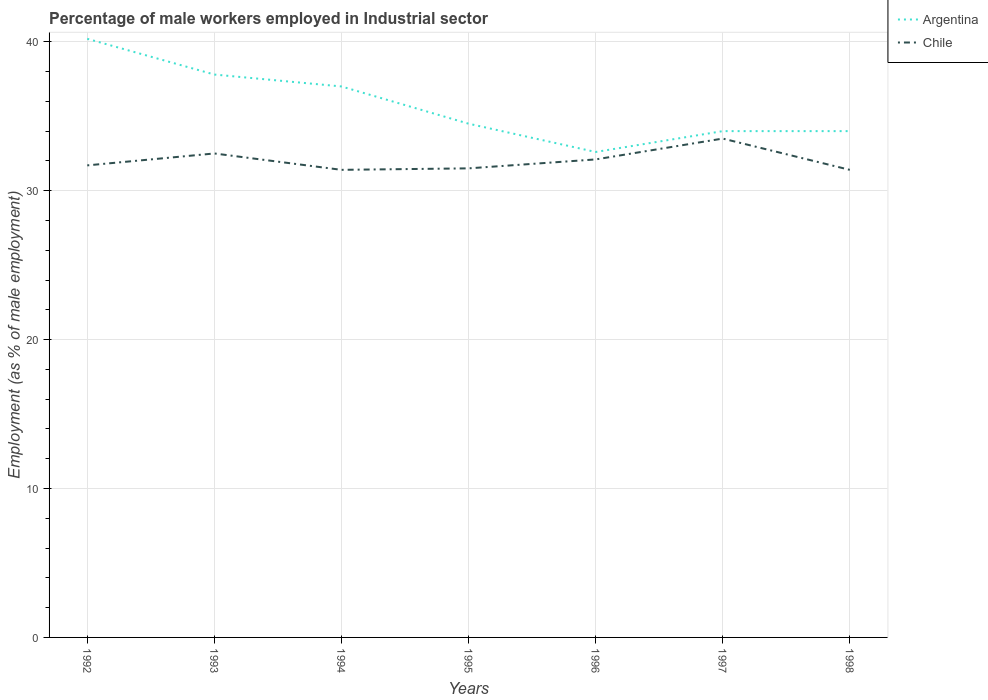Does the line corresponding to Argentina intersect with the line corresponding to Chile?
Give a very brief answer. No. Is the number of lines equal to the number of legend labels?
Your answer should be compact. Yes. Across all years, what is the maximum percentage of male workers employed in Industrial sector in Chile?
Your answer should be very brief. 31.4. In which year was the percentage of male workers employed in Industrial sector in Argentina maximum?
Your answer should be very brief. 1996. What is the total percentage of male workers employed in Industrial sector in Argentina in the graph?
Offer a terse response. 2.5. What is the difference between the highest and the second highest percentage of male workers employed in Industrial sector in Chile?
Provide a succinct answer. 2.1. Is the percentage of male workers employed in Industrial sector in Argentina strictly greater than the percentage of male workers employed in Industrial sector in Chile over the years?
Keep it short and to the point. No. How many years are there in the graph?
Offer a terse response. 7. What is the difference between two consecutive major ticks on the Y-axis?
Make the answer very short. 10. Are the values on the major ticks of Y-axis written in scientific E-notation?
Ensure brevity in your answer.  No. Does the graph contain any zero values?
Your answer should be compact. No. Where does the legend appear in the graph?
Your answer should be compact. Top right. How many legend labels are there?
Your answer should be compact. 2. What is the title of the graph?
Offer a terse response. Percentage of male workers employed in Industrial sector. What is the label or title of the Y-axis?
Offer a terse response. Employment (as % of male employment). What is the Employment (as % of male employment) of Argentina in 1992?
Offer a terse response. 40.2. What is the Employment (as % of male employment) of Chile in 1992?
Offer a very short reply. 31.7. What is the Employment (as % of male employment) in Argentina in 1993?
Offer a very short reply. 37.8. What is the Employment (as % of male employment) of Chile in 1993?
Give a very brief answer. 32.5. What is the Employment (as % of male employment) in Chile in 1994?
Provide a succinct answer. 31.4. What is the Employment (as % of male employment) of Argentina in 1995?
Keep it short and to the point. 34.5. What is the Employment (as % of male employment) in Chile in 1995?
Your response must be concise. 31.5. What is the Employment (as % of male employment) in Argentina in 1996?
Offer a terse response. 32.6. What is the Employment (as % of male employment) of Chile in 1996?
Your answer should be very brief. 32.1. What is the Employment (as % of male employment) of Argentina in 1997?
Provide a short and direct response. 34. What is the Employment (as % of male employment) of Chile in 1997?
Make the answer very short. 33.5. What is the Employment (as % of male employment) of Chile in 1998?
Your answer should be very brief. 31.4. Across all years, what is the maximum Employment (as % of male employment) of Argentina?
Keep it short and to the point. 40.2. Across all years, what is the maximum Employment (as % of male employment) in Chile?
Provide a short and direct response. 33.5. Across all years, what is the minimum Employment (as % of male employment) in Argentina?
Your response must be concise. 32.6. Across all years, what is the minimum Employment (as % of male employment) in Chile?
Provide a succinct answer. 31.4. What is the total Employment (as % of male employment) of Argentina in the graph?
Your answer should be compact. 250.1. What is the total Employment (as % of male employment) in Chile in the graph?
Give a very brief answer. 224.1. What is the difference between the Employment (as % of male employment) of Argentina in 1992 and that in 1993?
Give a very brief answer. 2.4. What is the difference between the Employment (as % of male employment) in Argentina in 1992 and that in 1994?
Offer a very short reply. 3.2. What is the difference between the Employment (as % of male employment) in Chile in 1992 and that in 1994?
Your answer should be very brief. 0.3. What is the difference between the Employment (as % of male employment) of Chile in 1992 and that in 1996?
Make the answer very short. -0.4. What is the difference between the Employment (as % of male employment) in Chile in 1992 and that in 1998?
Provide a short and direct response. 0.3. What is the difference between the Employment (as % of male employment) of Argentina in 1993 and that in 1994?
Provide a short and direct response. 0.8. What is the difference between the Employment (as % of male employment) in Chile in 1993 and that in 1994?
Make the answer very short. 1.1. What is the difference between the Employment (as % of male employment) of Chile in 1993 and that in 1995?
Keep it short and to the point. 1. What is the difference between the Employment (as % of male employment) of Argentina in 1993 and that in 1997?
Ensure brevity in your answer.  3.8. What is the difference between the Employment (as % of male employment) in Argentina in 1993 and that in 1998?
Keep it short and to the point. 3.8. What is the difference between the Employment (as % of male employment) in Argentina in 1994 and that in 1995?
Offer a terse response. 2.5. What is the difference between the Employment (as % of male employment) in Argentina in 1994 and that in 1996?
Your answer should be compact. 4.4. What is the difference between the Employment (as % of male employment) of Chile in 1994 and that in 1996?
Offer a terse response. -0.7. What is the difference between the Employment (as % of male employment) in Argentina in 1994 and that in 1998?
Provide a succinct answer. 3. What is the difference between the Employment (as % of male employment) of Chile in 1994 and that in 1998?
Offer a terse response. 0. What is the difference between the Employment (as % of male employment) of Argentina in 1995 and that in 1996?
Give a very brief answer. 1.9. What is the difference between the Employment (as % of male employment) of Chile in 1995 and that in 1996?
Your answer should be very brief. -0.6. What is the difference between the Employment (as % of male employment) of Argentina in 1995 and that in 1997?
Give a very brief answer. 0.5. What is the difference between the Employment (as % of male employment) of Chile in 1995 and that in 1997?
Your response must be concise. -2. What is the difference between the Employment (as % of male employment) of Argentina in 1995 and that in 1998?
Provide a succinct answer. 0.5. What is the difference between the Employment (as % of male employment) in Chile in 1996 and that in 1997?
Provide a short and direct response. -1.4. What is the difference between the Employment (as % of male employment) of Argentina in 1997 and that in 1998?
Give a very brief answer. 0. What is the difference between the Employment (as % of male employment) in Chile in 1997 and that in 1998?
Offer a terse response. 2.1. What is the difference between the Employment (as % of male employment) of Argentina in 1992 and the Employment (as % of male employment) of Chile in 1994?
Provide a succinct answer. 8.8. What is the difference between the Employment (as % of male employment) of Argentina in 1993 and the Employment (as % of male employment) of Chile in 1995?
Make the answer very short. 6.3. What is the difference between the Employment (as % of male employment) of Argentina in 1993 and the Employment (as % of male employment) of Chile in 1996?
Your response must be concise. 5.7. What is the difference between the Employment (as % of male employment) in Argentina in 1993 and the Employment (as % of male employment) in Chile in 1998?
Keep it short and to the point. 6.4. What is the difference between the Employment (as % of male employment) in Argentina in 1994 and the Employment (as % of male employment) in Chile in 1996?
Give a very brief answer. 4.9. What is the difference between the Employment (as % of male employment) in Argentina in 1994 and the Employment (as % of male employment) in Chile in 1997?
Ensure brevity in your answer.  3.5. What is the difference between the Employment (as % of male employment) of Argentina in 1995 and the Employment (as % of male employment) of Chile in 1997?
Provide a succinct answer. 1. What is the difference between the Employment (as % of male employment) in Argentina in 1995 and the Employment (as % of male employment) in Chile in 1998?
Offer a terse response. 3.1. What is the difference between the Employment (as % of male employment) of Argentina in 1997 and the Employment (as % of male employment) of Chile in 1998?
Your answer should be very brief. 2.6. What is the average Employment (as % of male employment) in Argentina per year?
Make the answer very short. 35.73. What is the average Employment (as % of male employment) in Chile per year?
Provide a succinct answer. 32.01. In the year 1992, what is the difference between the Employment (as % of male employment) of Argentina and Employment (as % of male employment) of Chile?
Offer a terse response. 8.5. In the year 1993, what is the difference between the Employment (as % of male employment) of Argentina and Employment (as % of male employment) of Chile?
Make the answer very short. 5.3. In the year 1994, what is the difference between the Employment (as % of male employment) in Argentina and Employment (as % of male employment) in Chile?
Your answer should be compact. 5.6. In the year 1997, what is the difference between the Employment (as % of male employment) of Argentina and Employment (as % of male employment) of Chile?
Give a very brief answer. 0.5. What is the ratio of the Employment (as % of male employment) of Argentina in 1992 to that in 1993?
Keep it short and to the point. 1.06. What is the ratio of the Employment (as % of male employment) in Chile in 1992 to that in 1993?
Your answer should be very brief. 0.98. What is the ratio of the Employment (as % of male employment) of Argentina in 1992 to that in 1994?
Provide a short and direct response. 1.09. What is the ratio of the Employment (as % of male employment) in Chile in 1992 to that in 1994?
Make the answer very short. 1.01. What is the ratio of the Employment (as % of male employment) in Argentina in 1992 to that in 1995?
Give a very brief answer. 1.17. What is the ratio of the Employment (as % of male employment) of Chile in 1992 to that in 1995?
Make the answer very short. 1.01. What is the ratio of the Employment (as % of male employment) of Argentina in 1992 to that in 1996?
Your answer should be very brief. 1.23. What is the ratio of the Employment (as % of male employment) of Chile in 1992 to that in 1996?
Keep it short and to the point. 0.99. What is the ratio of the Employment (as % of male employment) in Argentina in 1992 to that in 1997?
Offer a terse response. 1.18. What is the ratio of the Employment (as % of male employment) of Chile in 1992 to that in 1997?
Ensure brevity in your answer.  0.95. What is the ratio of the Employment (as % of male employment) of Argentina in 1992 to that in 1998?
Your answer should be compact. 1.18. What is the ratio of the Employment (as % of male employment) in Chile in 1992 to that in 1998?
Offer a terse response. 1.01. What is the ratio of the Employment (as % of male employment) in Argentina in 1993 to that in 1994?
Your answer should be very brief. 1.02. What is the ratio of the Employment (as % of male employment) in Chile in 1993 to that in 1994?
Your answer should be compact. 1.03. What is the ratio of the Employment (as % of male employment) of Argentina in 1993 to that in 1995?
Keep it short and to the point. 1.1. What is the ratio of the Employment (as % of male employment) in Chile in 1993 to that in 1995?
Keep it short and to the point. 1.03. What is the ratio of the Employment (as % of male employment) in Argentina in 1993 to that in 1996?
Your answer should be compact. 1.16. What is the ratio of the Employment (as % of male employment) of Chile in 1993 to that in 1996?
Make the answer very short. 1.01. What is the ratio of the Employment (as % of male employment) of Argentina in 1993 to that in 1997?
Ensure brevity in your answer.  1.11. What is the ratio of the Employment (as % of male employment) of Chile in 1993 to that in 1997?
Make the answer very short. 0.97. What is the ratio of the Employment (as % of male employment) of Argentina in 1993 to that in 1998?
Make the answer very short. 1.11. What is the ratio of the Employment (as % of male employment) in Chile in 1993 to that in 1998?
Offer a terse response. 1.03. What is the ratio of the Employment (as % of male employment) of Argentina in 1994 to that in 1995?
Ensure brevity in your answer.  1.07. What is the ratio of the Employment (as % of male employment) of Argentina in 1994 to that in 1996?
Your answer should be compact. 1.14. What is the ratio of the Employment (as % of male employment) in Chile in 1994 to that in 1996?
Offer a very short reply. 0.98. What is the ratio of the Employment (as % of male employment) of Argentina in 1994 to that in 1997?
Your answer should be compact. 1.09. What is the ratio of the Employment (as % of male employment) in Chile in 1994 to that in 1997?
Make the answer very short. 0.94. What is the ratio of the Employment (as % of male employment) in Argentina in 1994 to that in 1998?
Offer a very short reply. 1.09. What is the ratio of the Employment (as % of male employment) of Chile in 1994 to that in 1998?
Provide a short and direct response. 1. What is the ratio of the Employment (as % of male employment) of Argentina in 1995 to that in 1996?
Provide a short and direct response. 1.06. What is the ratio of the Employment (as % of male employment) of Chile in 1995 to that in 1996?
Provide a succinct answer. 0.98. What is the ratio of the Employment (as % of male employment) of Argentina in 1995 to that in 1997?
Your response must be concise. 1.01. What is the ratio of the Employment (as % of male employment) of Chile in 1995 to that in 1997?
Your response must be concise. 0.94. What is the ratio of the Employment (as % of male employment) in Argentina in 1995 to that in 1998?
Offer a very short reply. 1.01. What is the ratio of the Employment (as % of male employment) of Argentina in 1996 to that in 1997?
Your answer should be compact. 0.96. What is the ratio of the Employment (as % of male employment) of Chile in 1996 to that in 1997?
Provide a succinct answer. 0.96. What is the ratio of the Employment (as % of male employment) in Argentina in 1996 to that in 1998?
Provide a succinct answer. 0.96. What is the ratio of the Employment (as % of male employment) of Chile in 1996 to that in 1998?
Your answer should be compact. 1.02. What is the ratio of the Employment (as % of male employment) in Argentina in 1997 to that in 1998?
Provide a succinct answer. 1. What is the ratio of the Employment (as % of male employment) in Chile in 1997 to that in 1998?
Offer a terse response. 1.07. What is the difference between the highest and the lowest Employment (as % of male employment) of Chile?
Keep it short and to the point. 2.1. 